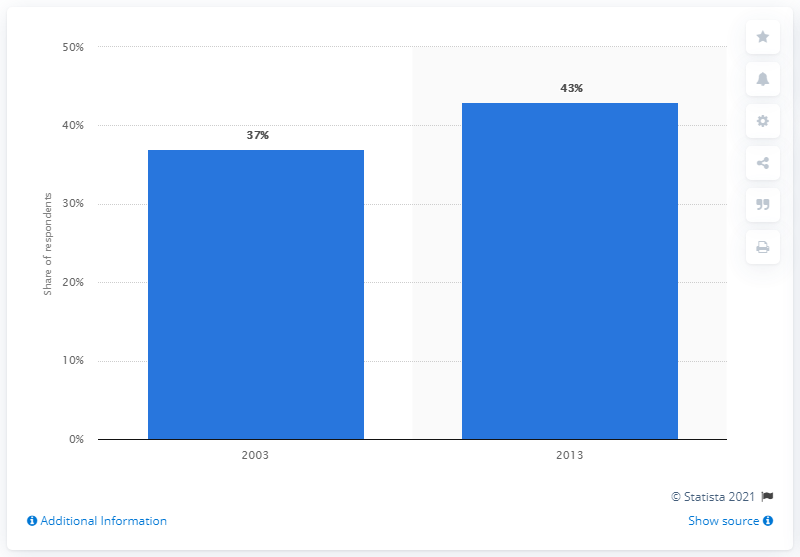Specify some key components in this picture. The years considered for the purpose of this analysis are 10... 